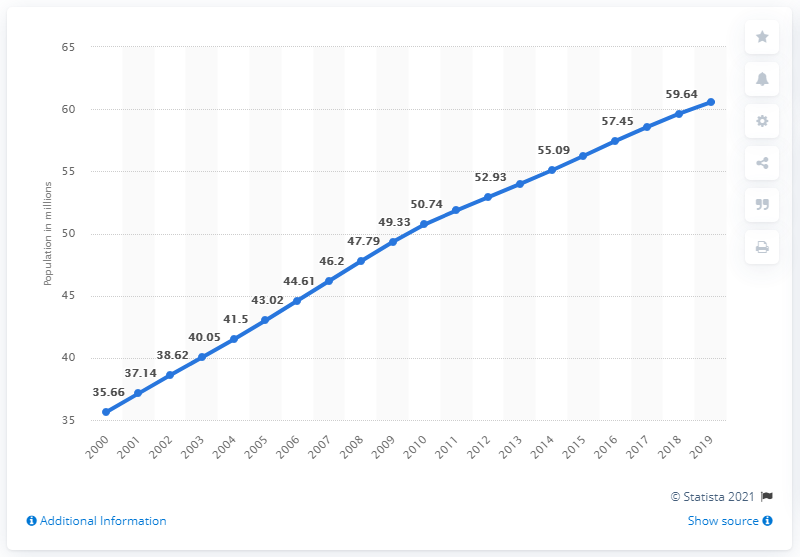Indicate a few pertinent items in this graphic. In 2019, it is estimated that 60.57% of the population in the United States had Hispanic origins. 